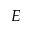Convert formula to latex. <formula><loc_0><loc_0><loc_500><loc_500>E</formula> 